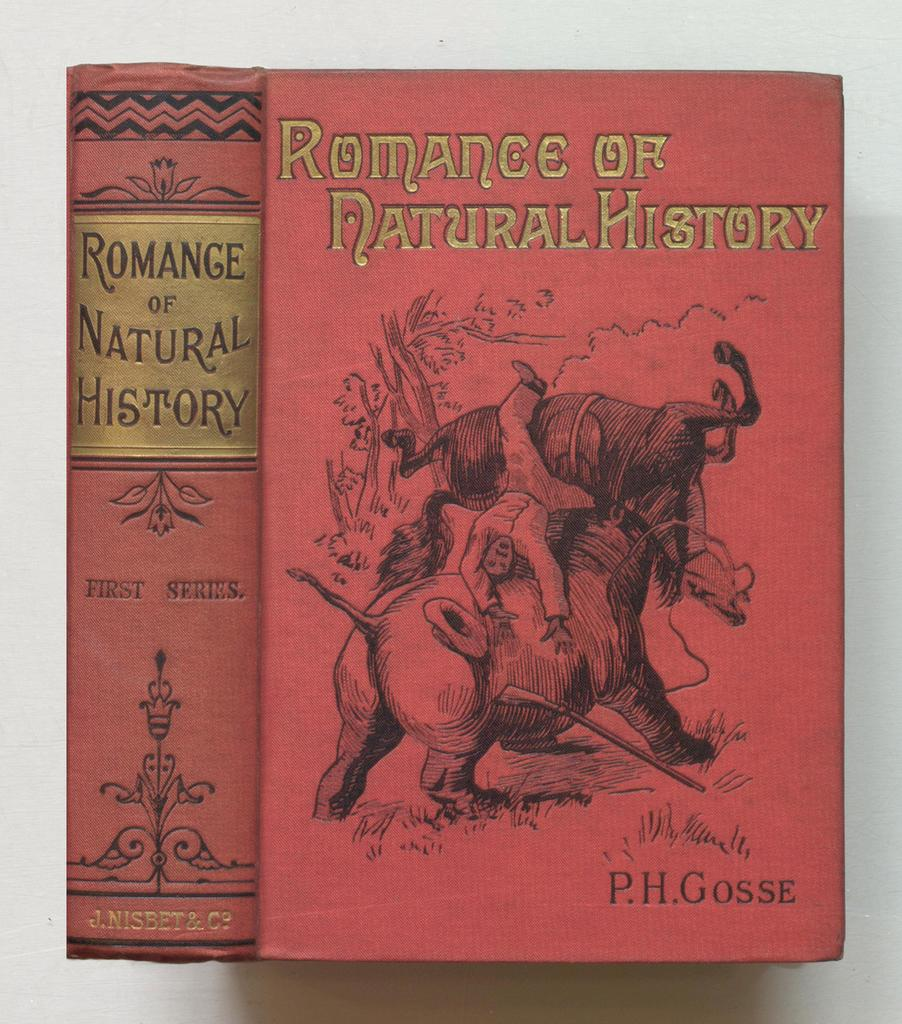<image>
Relay a brief, clear account of the picture shown. Red book named Romance of Natural History by P.H. Gosse. 